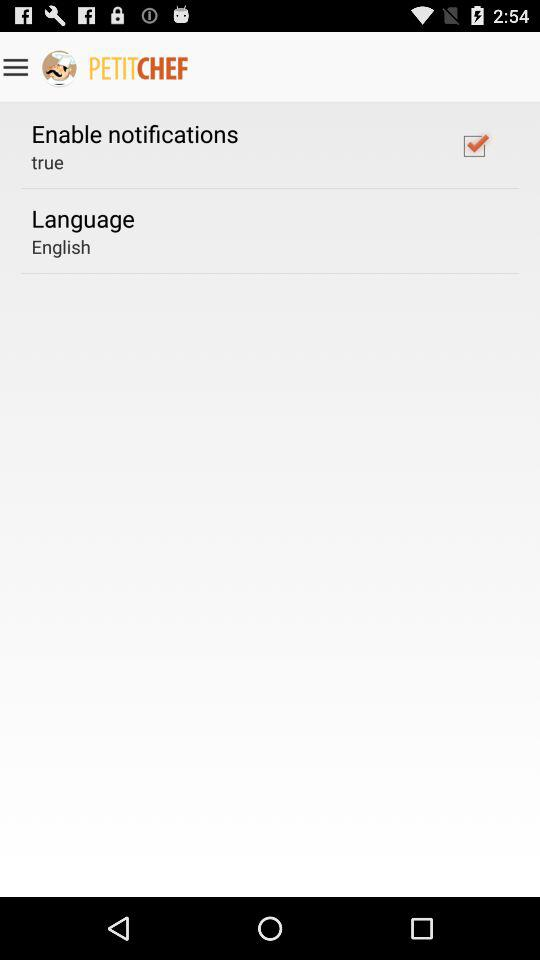What is the selected language? The selected language is English. 